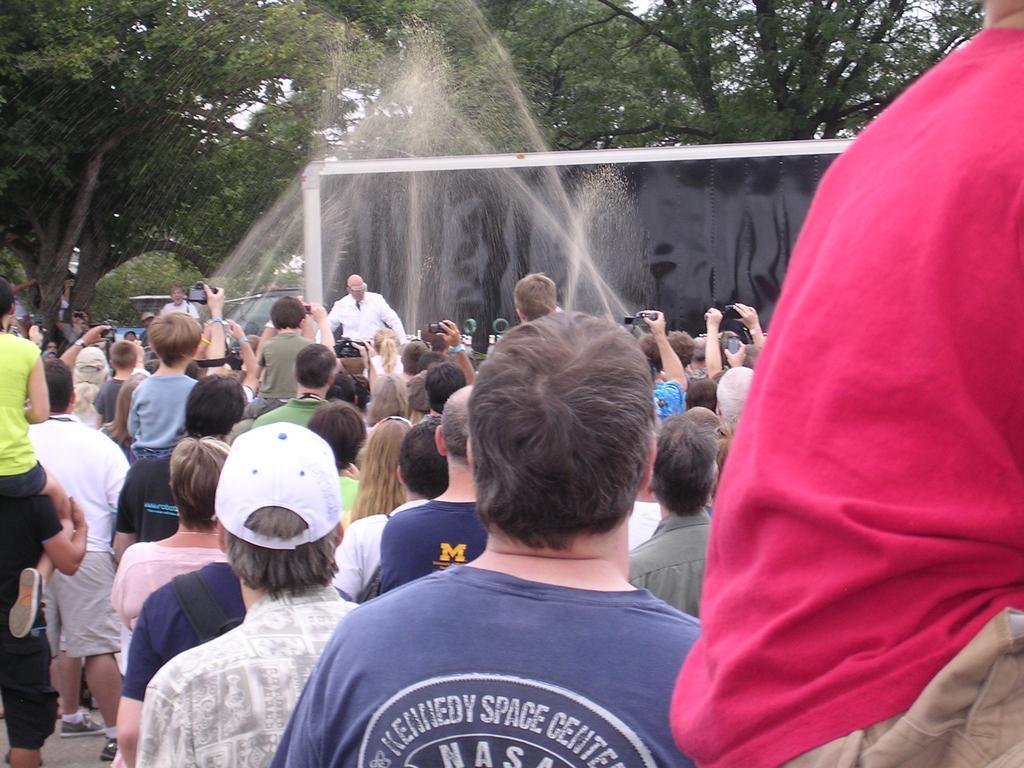How would you summarize this image in a sentence or two? In this picture, we see many people standing and enjoying the party. Man in blue shirt is holding the camera in his hand and he is clicking photos on the camera. Man in the white jacket is playing music. There are many trees in the background and this picture is clicked outside the city. 